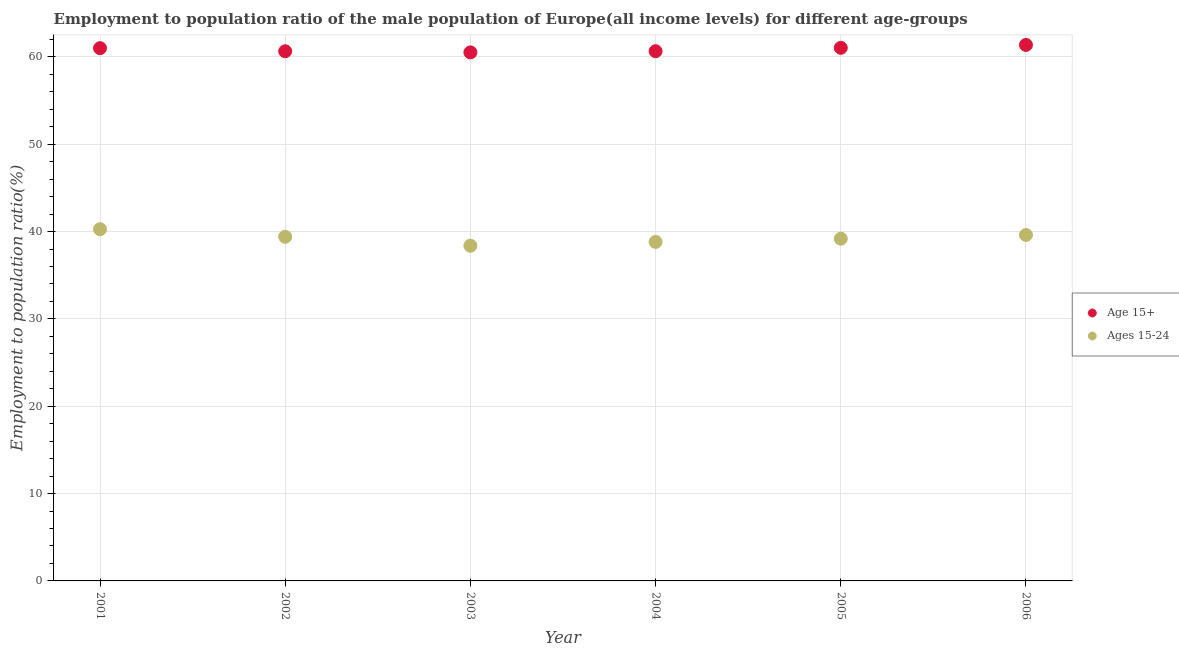How many different coloured dotlines are there?
Ensure brevity in your answer.  2. Is the number of dotlines equal to the number of legend labels?
Make the answer very short. Yes. What is the employment to population ratio(age 15+) in 2005?
Give a very brief answer. 61.04. Across all years, what is the maximum employment to population ratio(age 15-24)?
Make the answer very short. 40.27. Across all years, what is the minimum employment to population ratio(age 15-24)?
Ensure brevity in your answer.  38.38. In which year was the employment to population ratio(age 15-24) maximum?
Offer a very short reply. 2001. What is the total employment to population ratio(age 15+) in the graph?
Ensure brevity in your answer.  365.22. What is the difference between the employment to population ratio(age 15+) in 2004 and that in 2005?
Offer a very short reply. -0.39. What is the difference between the employment to population ratio(age 15-24) in 2002 and the employment to population ratio(age 15+) in 2005?
Provide a short and direct response. -21.64. What is the average employment to population ratio(age 15+) per year?
Offer a terse response. 60.87. In the year 2001, what is the difference between the employment to population ratio(age 15-24) and employment to population ratio(age 15+)?
Keep it short and to the point. -20.73. What is the ratio of the employment to population ratio(age 15+) in 2002 to that in 2006?
Your answer should be very brief. 0.99. Is the difference between the employment to population ratio(age 15+) in 2001 and 2005 greater than the difference between the employment to population ratio(age 15-24) in 2001 and 2005?
Offer a very short reply. No. What is the difference between the highest and the second highest employment to population ratio(age 15+)?
Offer a very short reply. 0.33. What is the difference between the highest and the lowest employment to population ratio(age 15+)?
Your answer should be very brief. 0.85. In how many years, is the employment to population ratio(age 15-24) greater than the average employment to population ratio(age 15-24) taken over all years?
Ensure brevity in your answer.  3. Is the employment to population ratio(age 15-24) strictly less than the employment to population ratio(age 15+) over the years?
Your answer should be compact. Yes. How many dotlines are there?
Make the answer very short. 2. Does the graph contain any zero values?
Offer a very short reply. No. Does the graph contain grids?
Ensure brevity in your answer.  Yes. What is the title of the graph?
Offer a terse response. Employment to population ratio of the male population of Europe(all income levels) for different age-groups. Does "Diarrhea" appear as one of the legend labels in the graph?
Give a very brief answer. No. What is the Employment to population ratio(%) of Age 15+ in 2001?
Keep it short and to the point. 61. What is the Employment to population ratio(%) of Ages 15-24 in 2001?
Provide a succinct answer. 40.27. What is the Employment to population ratio(%) in Age 15+ in 2002?
Your response must be concise. 60.65. What is the Employment to population ratio(%) in Ages 15-24 in 2002?
Provide a succinct answer. 39.4. What is the Employment to population ratio(%) in Age 15+ in 2003?
Keep it short and to the point. 60.52. What is the Employment to population ratio(%) of Ages 15-24 in 2003?
Your response must be concise. 38.38. What is the Employment to population ratio(%) of Age 15+ in 2004?
Your answer should be very brief. 60.65. What is the Employment to population ratio(%) in Ages 15-24 in 2004?
Offer a very short reply. 38.81. What is the Employment to population ratio(%) in Age 15+ in 2005?
Ensure brevity in your answer.  61.04. What is the Employment to population ratio(%) in Ages 15-24 in 2005?
Keep it short and to the point. 39.18. What is the Employment to population ratio(%) in Age 15+ in 2006?
Provide a succinct answer. 61.37. What is the Employment to population ratio(%) of Ages 15-24 in 2006?
Provide a short and direct response. 39.61. Across all years, what is the maximum Employment to population ratio(%) in Age 15+?
Make the answer very short. 61.37. Across all years, what is the maximum Employment to population ratio(%) of Ages 15-24?
Make the answer very short. 40.27. Across all years, what is the minimum Employment to population ratio(%) of Age 15+?
Offer a terse response. 60.52. Across all years, what is the minimum Employment to population ratio(%) in Ages 15-24?
Ensure brevity in your answer.  38.38. What is the total Employment to population ratio(%) of Age 15+ in the graph?
Ensure brevity in your answer.  365.22. What is the total Employment to population ratio(%) in Ages 15-24 in the graph?
Provide a short and direct response. 235.65. What is the difference between the Employment to population ratio(%) in Age 15+ in 2001 and that in 2002?
Provide a short and direct response. 0.35. What is the difference between the Employment to population ratio(%) in Ages 15-24 in 2001 and that in 2002?
Offer a terse response. 0.87. What is the difference between the Employment to population ratio(%) in Age 15+ in 2001 and that in 2003?
Keep it short and to the point. 0.48. What is the difference between the Employment to population ratio(%) of Ages 15-24 in 2001 and that in 2003?
Offer a very short reply. 1.89. What is the difference between the Employment to population ratio(%) of Age 15+ in 2001 and that in 2004?
Offer a very short reply. 0.35. What is the difference between the Employment to population ratio(%) of Ages 15-24 in 2001 and that in 2004?
Keep it short and to the point. 1.45. What is the difference between the Employment to population ratio(%) of Age 15+ in 2001 and that in 2005?
Your answer should be very brief. -0.04. What is the difference between the Employment to population ratio(%) of Ages 15-24 in 2001 and that in 2005?
Your answer should be very brief. 1.08. What is the difference between the Employment to population ratio(%) in Age 15+ in 2001 and that in 2006?
Your answer should be compact. -0.37. What is the difference between the Employment to population ratio(%) of Ages 15-24 in 2001 and that in 2006?
Provide a succinct answer. 0.66. What is the difference between the Employment to population ratio(%) of Age 15+ in 2002 and that in 2003?
Provide a short and direct response. 0.13. What is the difference between the Employment to population ratio(%) of Ages 15-24 in 2002 and that in 2003?
Provide a succinct answer. 1.02. What is the difference between the Employment to population ratio(%) in Age 15+ in 2002 and that in 2004?
Your response must be concise. -0.01. What is the difference between the Employment to population ratio(%) in Ages 15-24 in 2002 and that in 2004?
Offer a very short reply. 0.59. What is the difference between the Employment to population ratio(%) in Age 15+ in 2002 and that in 2005?
Give a very brief answer. -0.39. What is the difference between the Employment to population ratio(%) of Ages 15-24 in 2002 and that in 2005?
Make the answer very short. 0.22. What is the difference between the Employment to population ratio(%) of Age 15+ in 2002 and that in 2006?
Provide a short and direct response. -0.73. What is the difference between the Employment to population ratio(%) of Ages 15-24 in 2002 and that in 2006?
Provide a succinct answer. -0.21. What is the difference between the Employment to population ratio(%) of Age 15+ in 2003 and that in 2004?
Offer a very short reply. -0.14. What is the difference between the Employment to population ratio(%) of Ages 15-24 in 2003 and that in 2004?
Provide a succinct answer. -0.44. What is the difference between the Employment to population ratio(%) in Age 15+ in 2003 and that in 2005?
Your answer should be very brief. -0.52. What is the difference between the Employment to population ratio(%) in Ages 15-24 in 2003 and that in 2005?
Offer a very short reply. -0.81. What is the difference between the Employment to population ratio(%) of Age 15+ in 2003 and that in 2006?
Offer a terse response. -0.85. What is the difference between the Employment to population ratio(%) in Ages 15-24 in 2003 and that in 2006?
Provide a short and direct response. -1.23. What is the difference between the Employment to population ratio(%) in Age 15+ in 2004 and that in 2005?
Make the answer very short. -0.39. What is the difference between the Employment to population ratio(%) of Ages 15-24 in 2004 and that in 2005?
Offer a very short reply. -0.37. What is the difference between the Employment to population ratio(%) of Age 15+ in 2004 and that in 2006?
Provide a succinct answer. -0.72. What is the difference between the Employment to population ratio(%) of Ages 15-24 in 2004 and that in 2006?
Offer a very short reply. -0.79. What is the difference between the Employment to population ratio(%) of Age 15+ in 2005 and that in 2006?
Provide a short and direct response. -0.33. What is the difference between the Employment to population ratio(%) in Ages 15-24 in 2005 and that in 2006?
Your answer should be compact. -0.43. What is the difference between the Employment to population ratio(%) of Age 15+ in 2001 and the Employment to population ratio(%) of Ages 15-24 in 2002?
Provide a short and direct response. 21.6. What is the difference between the Employment to population ratio(%) in Age 15+ in 2001 and the Employment to population ratio(%) in Ages 15-24 in 2003?
Make the answer very short. 22.62. What is the difference between the Employment to population ratio(%) in Age 15+ in 2001 and the Employment to population ratio(%) in Ages 15-24 in 2004?
Offer a very short reply. 22.18. What is the difference between the Employment to population ratio(%) of Age 15+ in 2001 and the Employment to population ratio(%) of Ages 15-24 in 2005?
Provide a succinct answer. 21.81. What is the difference between the Employment to population ratio(%) in Age 15+ in 2001 and the Employment to population ratio(%) in Ages 15-24 in 2006?
Provide a short and direct response. 21.39. What is the difference between the Employment to population ratio(%) in Age 15+ in 2002 and the Employment to population ratio(%) in Ages 15-24 in 2003?
Make the answer very short. 22.27. What is the difference between the Employment to population ratio(%) of Age 15+ in 2002 and the Employment to population ratio(%) of Ages 15-24 in 2004?
Your answer should be very brief. 21.83. What is the difference between the Employment to population ratio(%) of Age 15+ in 2002 and the Employment to population ratio(%) of Ages 15-24 in 2005?
Your answer should be very brief. 21.46. What is the difference between the Employment to population ratio(%) of Age 15+ in 2002 and the Employment to population ratio(%) of Ages 15-24 in 2006?
Provide a succinct answer. 21.04. What is the difference between the Employment to population ratio(%) of Age 15+ in 2003 and the Employment to population ratio(%) of Ages 15-24 in 2004?
Your answer should be very brief. 21.7. What is the difference between the Employment to population ratio(%) of Age 15+ in 2003 and the Employment to population ratio(%) of Ages 15-24 in 2005?
Your answer should be compact. 21.33. What is the difference between the Employment to population ratio(%) of Age 15+ in 2003 and the Employment to population ratio(%) of Ages 15-24 in 2006?
Provide a succinct answer. 20.91. What is the difference between the Employment to population ratio(%) in Age 15+ in 2004 and the Employment to population ratio(%) in Ages 15-24 in 2005?
Your answer should be very brief. 21.47. What is the difference between the Employment to population ratio(%) of Age 15+ in 2004 and the Employment to population ratio(%) of Ages 15-24 in 2006?
Offer a very short reply. 21.04. What is the difference between the Employment to population ratio(%) of Age 15+ in 2005 and the Employment to population ratio(%) of Ages 15-24 in 2006?
Provide a short and direct response. 21.43. What is the average Employment to population ratio(%) in Age 15+ per year?
Offer a very short reply. 60.87. What is the average Employment to population ratio(%) in Ages 15-24 per year?
Keep it short and to the point. 39.28. In the year 2001, what is the difference between the Employment to population ratio(%) of Age 15+ and Employment to population ratio(%) of Ages 15-24?
Offer a terse response. 20.73. In the year 2002, what is the difference between the Employment to population ratio(%) of Age 15+ and Employment to population ratio(%) of Ages 15-24?
Your response must be concise. 21.25. In the year 2003, what is the difference between the Employment to population ratio(%) of Age 15+ and Employment to population ratio(%) of Ages 15-24?
Offer a very short reply. 22.14. In the year 2004, what is the difference between the Employment to population ratio(%) of Age 15+ and Employment to population ratio(%) of Ages 15-24?
Keep it short and to the point. 21.84. In the year 2005, what is the difference between the Employment to population ratio(%) of Age 15+ and Employment to population ratio(%) of Ages 15-24?
Keep it short and to the point. 21.85. In the year 2006, what is the difference between the Employment to population ratio(%) of Age 15+ and Employment to population ratio(%) of Ages 15-24?
Keep it short and to the point. 21.76. What is the ratio of the Employment to population ratio(%) of Age 15+ in 2001 to that in 2002?
Offer a very short reply. 1.01. What is the ratio of the Employment to population ratio(%) in Ages 15-24 in 2001 to that in 2002?
Provide a succinct answer. 1.02. What is the ratio of the Employment to population ratio(%) in Age 15+ in 2001 to that in 2003?
Your answer should be very brief. 1.01. What is the ratio of the Employment to population ratio(%) of Ages 15-24 in 2001 to that in 2003?
Provide a short and direct response. 1.05. What is the ratio of the Employment to population ratio(%) of Ages 15-24 in 2001 to that in 2004?
Your answer should be very brief. 1.04. What is the ratio of the Employment to population ratio(%) of Ages 15-24 in 2001 to that in 2005?
Your answer should be very brief. 1.03. What is the ratio of the Employment to population ratio(%) in Ages 15-24 in 2001 to that in 2006?
Your response must be concise. 1.02. What is the ratio of the Employment to population ratio(%) of Ages 15-24 in 2002 to that in 2003?
Keep it short and to the point. 1.03. What is the ratio of the Employment to population ratio(%) of Age 15+ in 2002 to that in 2004?
Your response must be concise. 1. What is the ratio of the Employment to population ratio(%) in Ages 15-24 in 2002 to that in 2004?
Provide a short and direct response. 1.02. What is the ratio of the Employment to population ratio(%) of Age 15+ in 2002 to that in 2005?
Ensure brevity in your answer.  0.99. What is the ratio of the Employment to population ratio(%) in Ages 15-24 in 2002 to that in 2005?
Offer a very short reply. 1.01. What is the ratio of the Employment to population ratio(%) in Ages 15-24 in 2002 to that in 2006?
Your answer should be compact. 0.99. What is the ratio of the Employment to population ratio(%) of Age 15+ in 2003 to that in 2004?
Keep it short and to the point. 1. What is the ratio of the Employment to population ratio(%) of Ages 15-24 in 2003 to that in 2004?
Make the answer very short. 0.99. What is the ratio of the Employment to population ratio(%) of Age 15+ in 2003 to that in 2005?
Provide a succinct answer. 0.99. What is the ratio of the Employment to population ratio(%) of Ages 15-24 in 2003 to that in 2005?
Offer a very short reply. 0.98. What is the ratio of the Employment to population ratio(%) of Age 15+ in 2003 to that in 2006?
Make the answer very short. 0.99. What is the ratio of the Employment to population ratio(%) in Ages 15-24 in 2003 to that in 2006?
Make the answer very short. 0.97. What is the ratio of the Employment to population ratio(%) in Ages 15-24 in 2004 to that in 2005?
Keep it short and to the point. 0.99. What is the ratio of the Employment to population ratio(%) of Age 15+ in 2004 to that in 2006?
Keep it short and to the point. 0.99. What is the ratio of the Employment to population ratio(%) of Ages 15-24 in 2004 to that in 2006?
Your response must be concise. 0.98. What is the ratio of the Employment to population ratio(%) in Age 15+ in 2005 to that in 2006?
Provide a succinct answer. 0.99. What is the ratio of the Employment to population ratio(%) in Ages 15-24 in 2005 to that in 2006?
Offer a terse response. 0.99. What is the difference between the highest and the second highest Employment to population ratio(%) in Age 15+?
Your response must be concise. 0.33. What is the difference between the highest and the second highest Employment to population ratio(%) of Ages 15-24?
Ensure brevity in your answer.  0.66. What is the difference between the highest and the lowest Employment to population ratio(%) in Age 15+?
Your answer should be compact. 0.85. What is the difference between the highest and the lowest Employment to population ratio(%) in Ages 15-24?
Give a very brief answer. 1.89. 